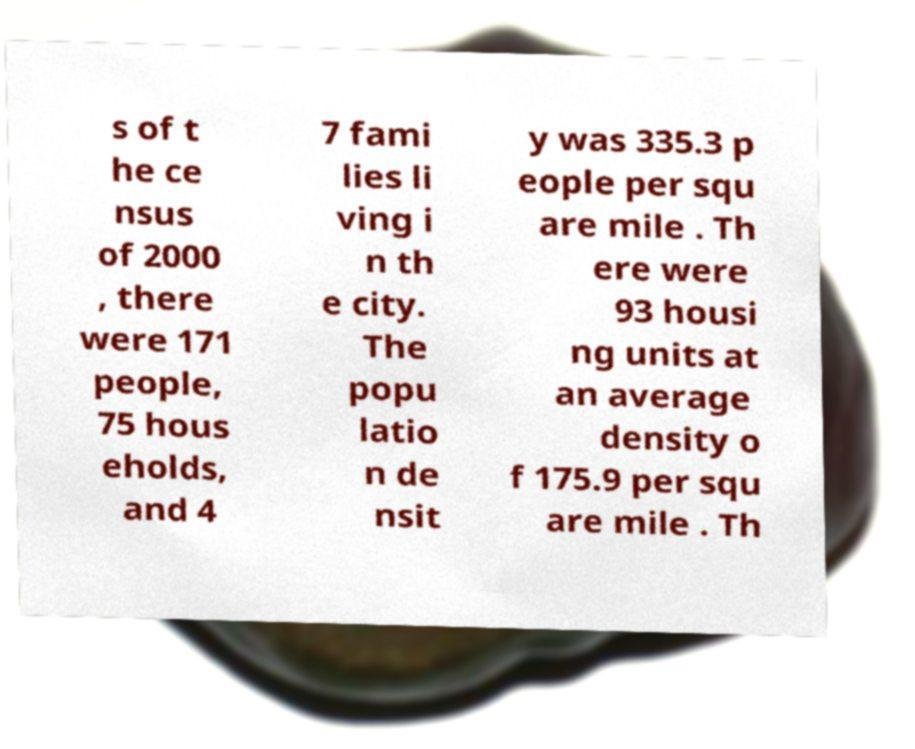Could you assist in decoding the text presented in this image and type it out clearly? s of t he ce nsus of 2000 , there were 171 people, 75 hous eholds, and 4 7 fami lies li ving i n th e city. The popu latio n de nsit y was 335.3 p eople per squ are mile . Th ere were 93 housi ng units at an average density o f 175.9 per squ are mile . Th 